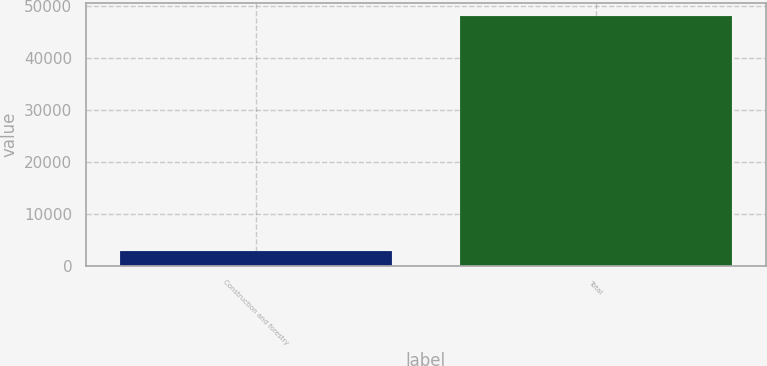Convert chart to OTSL. <chart><loc_0><loc_0><loc_500><loc_500><bar_chart><fcel>Construction and forestry<fcel>Total<nl><fcel>2915<fcel>48207<nl></chart> 